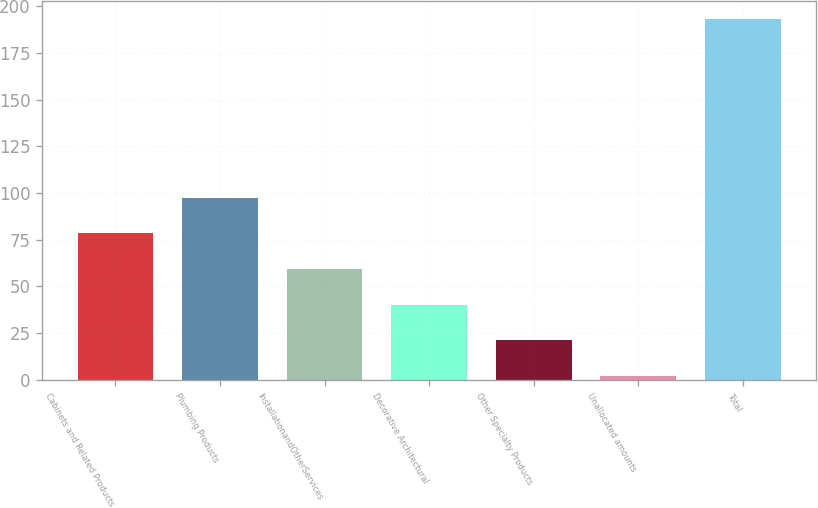Convert chart. <chart><loc_0><loc_0><loc_500><loc_500><bar_chart><fcel>Cabinets and Related Products<fcel>Plumbing Products<fcel>InstallationandOtherServices<fcel>Decorative Architectural<fcel>Other Specialty Products<fcel>Unallocated amounts<fcel>Total<nl><fcel>78.4<fcel>97.5<fcel>59.3<fcel>40.2<fcel>21.1<fcel>2<fcel>193<nl></chart> 